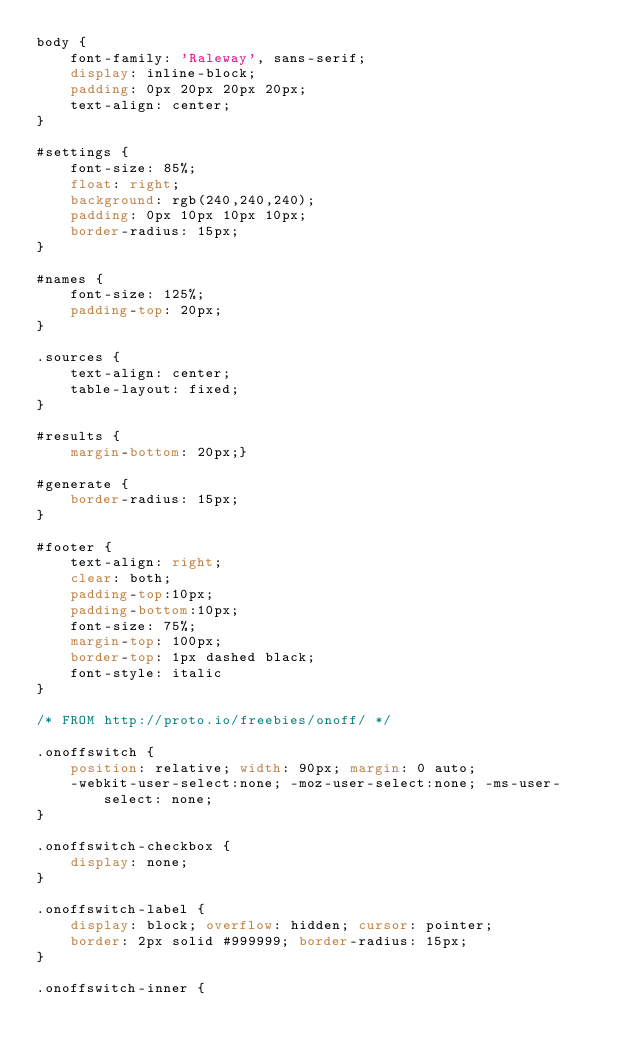<code> <loc_0><loc_0><loc_500><loc_500><_CSS_>body {
	font-family: 'Raleway', sans-serif;
	display: inline-block;
	padding: 0px 20px 20px 20px;
	text-align: center;
}

#settings {
	font-size: 85%;
	float: right;
	background: rgb(240,240,240);
	padding: 0px 10px 10px 10px;
	border-radius: 15px;
}

#names {
	font-size: 125%;
	padding-top: 20px;
}

.sources {
	text-align: center;
	table-layout: fixed;	
}

#results {
	margin-bottom: 20px;}

#generate {
	border-radius: 15px;
}

#footer {
	text-align: right;
	clear: both;
	padding-top:10px;
	padding-bottom:10px;
	font-size: 75%;
	margin-top: 100px;
	border-top:	1px dashed black;
	font-style: italic
}

/* FROM http://proto.io/freebies/onoff/ */

.onoffswitch {
    position: relative; width: 90px; margin: 0 auto;
    -webkit-user-select:none; -moz-user-select:none; -ms-user-select: none;
}

.onoffswitch-checkbox {
    display: none;
}

.onoffswitch-label {
    display: block; overflow: hidden; cursor: pointer;
    border: 2px solid #999999; border-radius: 15px;
}

.onoffswitch-inner {</code> 